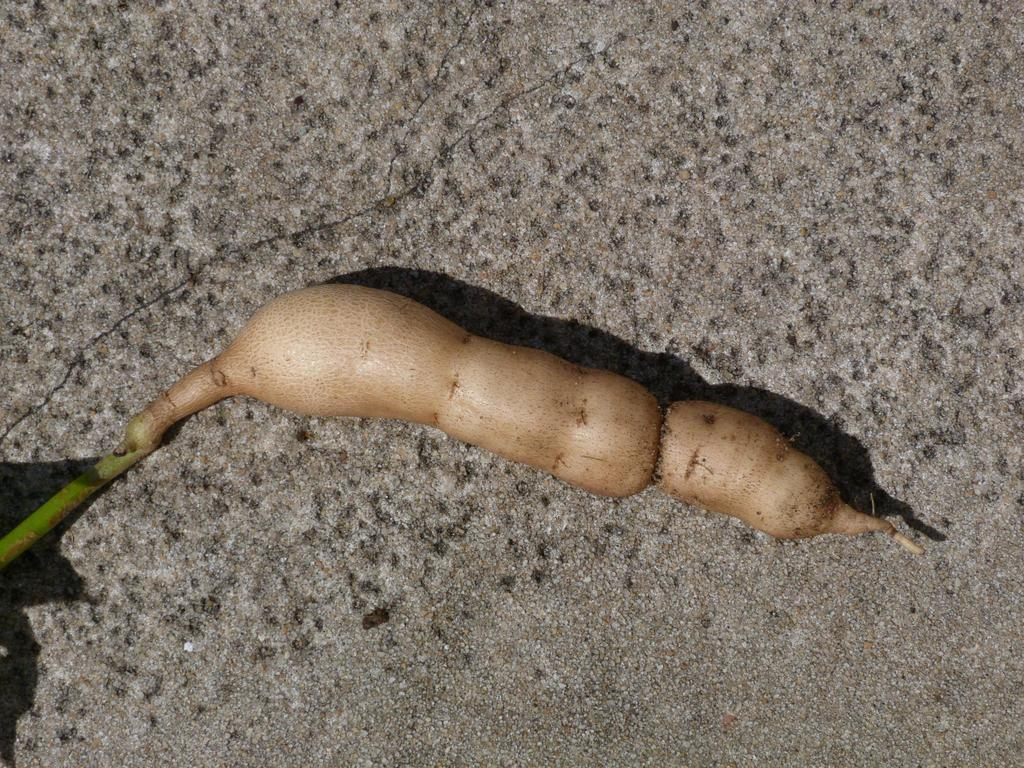What is located on the ground in the foreground of the image? There is a vegetable on the ground in the foreground of the image. Can you describe the lighting conditions in the image? The image was likely taken during the day, as there is sufficient light to see the vegetable clearly. How many tickets are attached to the string in the image? There is no string or tickets present in the image; it only features a vegetable on the ground. 